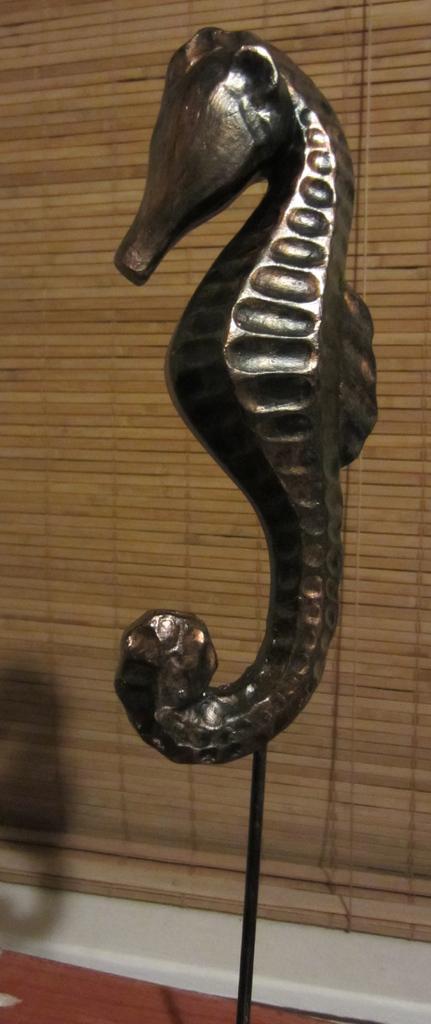In one or two sentences, can you explain what this image depicts? In this image we can see the depiction of a seahorse. In the background we can see the window mat. 